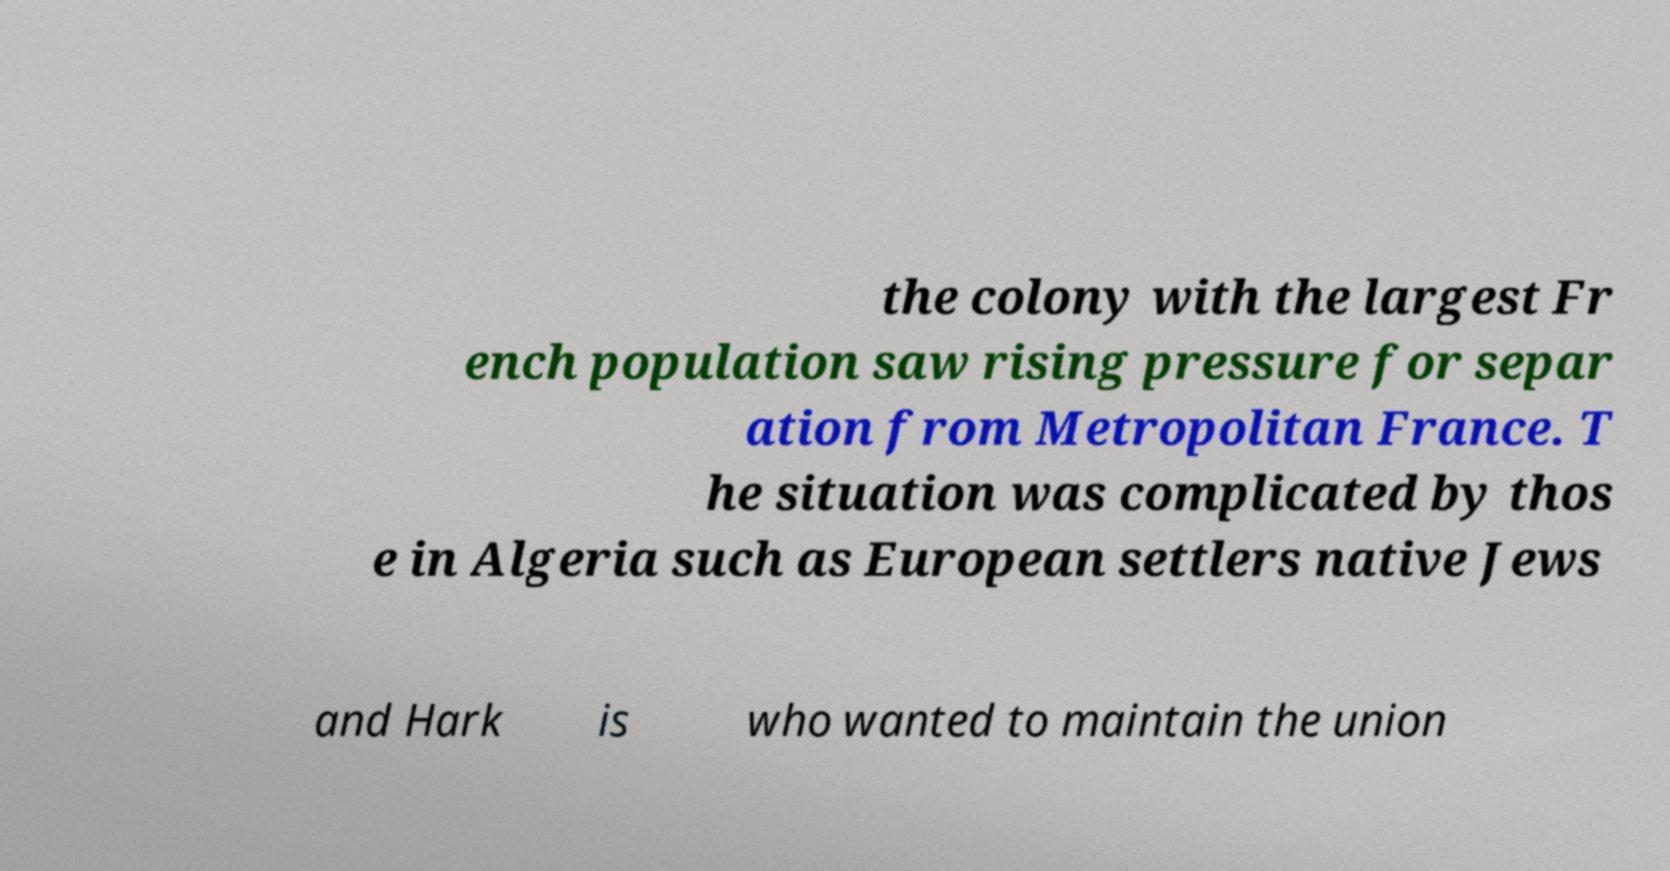For documentation purposes, I need the text within this image transcribed. Could you provide that? the colony with the largest Fr ench population saw rising pressure for separ ation from Metropolitan France. T he situation was complicated by thos e in Algeria such as European settlers native Jews and Hark is who wanted to maintain the union 